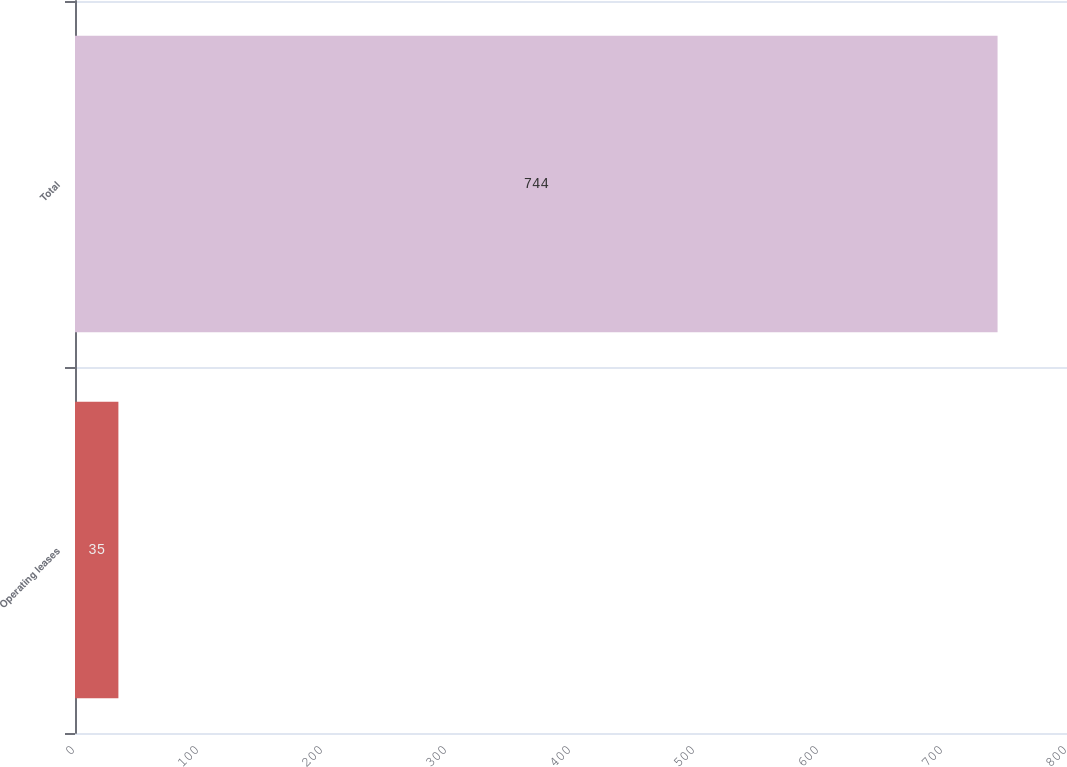Convert chart. <chart><loc_0><loc_0><loc_500><loc_500><bar_chart><fcel>Operating leases<fcel>Total<nl><fcel>35<fcel>744<nl></chart> 